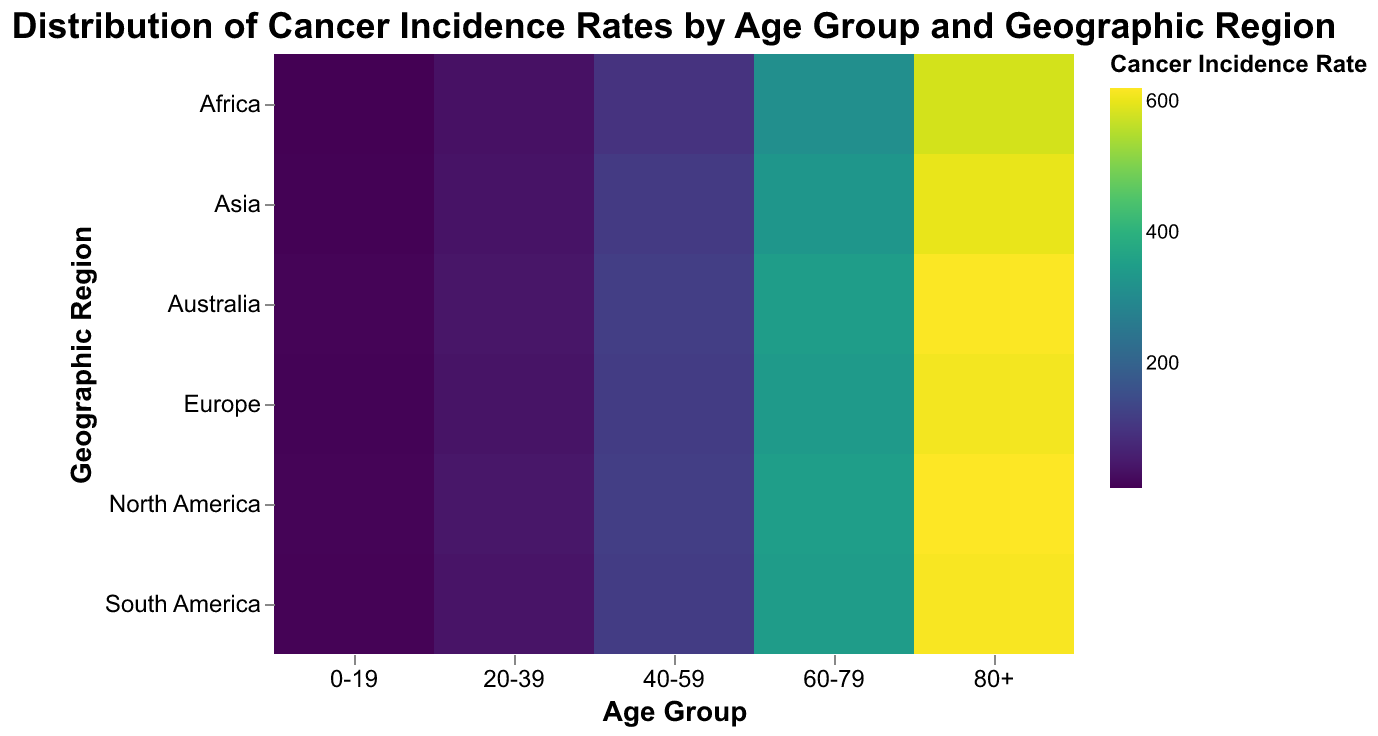What is the title of the heatmap? The title of the heatmap is prominently displayed at the top of the figure and reads "Distribution of Cancer Incidence Rates by Age Group and Geographic Region".
Answer: Distribution of Cancer Incidence Rates by Age Group and Geographic Region Which geographic region has the highest cancer incidence rate in the 80+ age group? By looking at the color gradient representing the cancer incidence rate, North America has the darkest shade in the 80+ age group column, indicating the highest rate of 620.6 per 100,000.
Answer: North America What is the cancer incidence rate for the 40-59 age group in Australia? Locate the intersection of the "Australia" row and the "40-59" column on the heatmap; the value is 119.9 per 100,000.
Answer: 119.9 Compare the cancer incidence rates of the 20-39 and 60-79 age groups in Europe. Which one is higher? The cancer incidence rate for the 20-39 age group in Europe is 40.3, while for the 60-79 age group, it is 340.2. Since 340.2 is greater than 40.3, the 60-79 age group has a higher rate.
Answer: 60-79 age group What is the average cancer incidence rate for all geographic regions in the 0-19 age group? The rates for each region in the 0-19 age group are: 15.2 (North America), 12.5 (Europe), 11.8 (Asia), 13.4 (South America), 10.0 (Africa), and 14.8 (Australia). Sum these values: 15.2 + 12.5 + 11.8 + 13.4 + 10.0 + 14.8 = 77.7. Divide by the number of regions (6): 77.7 / 6 = 12.95.
Answer: 12.95 Between Asia and South America, which geographic region has a higher cancer incidence rate in the 60-79 age group? Locate the values at the intersection of the regions (Asia and South America) and the 60-79 age group column. Asia has a rate of 330.8, and South America has a rate of 345.9. Since 345.9 is greater than 330.8, South America has a higher rate.
Answer: South America What is the lowest cancer incidence rate among all age groups and geographic regions? Scan the heatmap and look for the lightest color shade, which corresponds to the lowest incidence rate. The lowest rate is 10.0, found in Africa for the 0-19 age group.
Answer: 10.0 In which age group does Europe have the lowest cancer incidence rate? For Europe, the incidence rates across age groups are: 12.5 (0-19), 40.3 (20-39), 115.9 (40-59), 340.2 (60-79), and 610.5 (80+). The lowest rate is 12.5 in the 0-19 age group.
Answer: 0-19 What can you infer about the correlation between age group and cancer incidence rate across all regions? By observing the heatmap, we see that the color shades generally become darker as the age group increases from "0-19" to "80+", indicating that cancer incidence rates tend to increase with age across all geographic regions.
Answer: Cancer incidence rates increase with age across all regions 